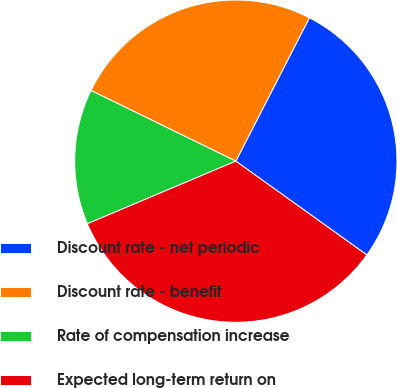<chart> <loc_0><loc_0><loc_500><loc_500><pie_chart><fcel>Discount rate - net periodic<fcel>Discount rate - benefit<fcel>Rate of compensation increase<fcel>Expected long-term return on<nl><fcel>27.34%<fcel>25.32%<fcel>13.58%<fcel>33.76%<nl></chart> 